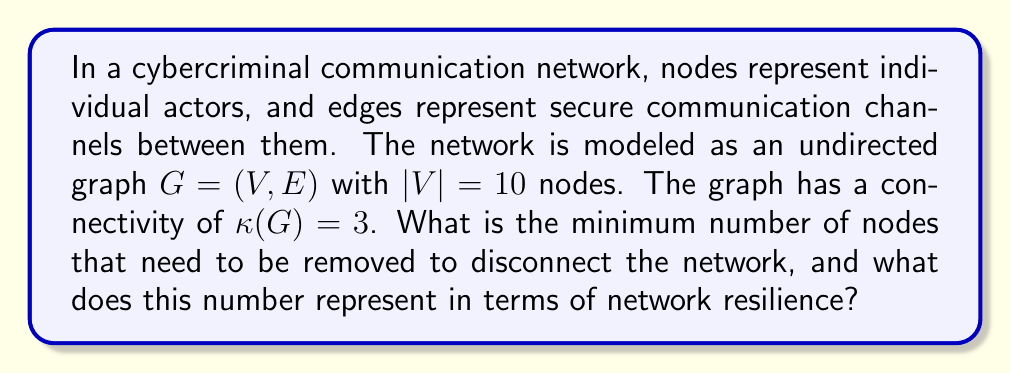What is the answer to this math problem? To solve this problem, we need to understand the concept of vertex connectivity in graph theory:

1. Vertex connectivity $\kappa(G)$ is defined as the minimum number of vertices whose removal results in a disconnected graph or a trivial graph.

2. Given that $\kappa(G)=3$ for this network, it means:
   a. The graph remains connected if we remove any 2 vertices.
   b. There exists a set of 3 vertices whose removal disconnects the graph.

3. In the context of a cybercriminal network:
   - Each node represents a key actor in the network.
   - The vertex connectivity represents the network's resilience against targeted attacks or law enforcement interventions.

4. The minimum number of nodes to disconnect the network is equal to $\kappa(G)$, which is 3 in this case.

5. This number (3) represents:
   a. The minimum number of actors that need to be removed or neutralized to break the network's communication structure.
   b. The level of redundancy built into the network to maintain connectivity.

6. From a cybersecurity perspective, this indicates that the network is moderately resilient, as it requires targeting at least 3 key actors to disrupt the entire communication structure.
Answer: The minimum number of nodes to disconnect the network is 3. This represents the network's vertex connectivity $\kappa(G)$, indicating a moderate level of resilience against targeted removals of key actors in the cybercriminal communication network. 